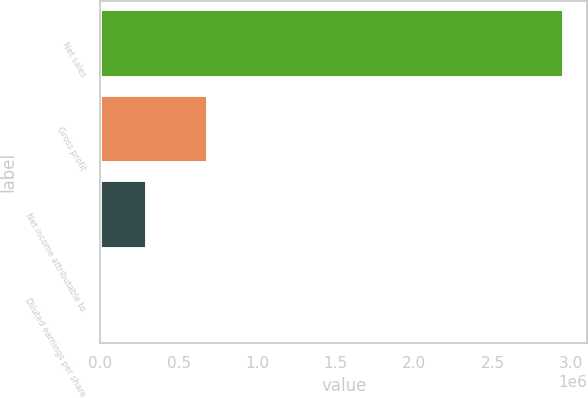<chart> <loc_0><loc_0><loc_500><loc_500><bar_chart><fcel>Net sales<fcel>Gross profit<fcel>Net income attributable to<fcel>Diluted earnings per share<nl><fcel>2.95715e+06<fcel>684695<fcel>295717<fcel>1.77<nl></chart> 